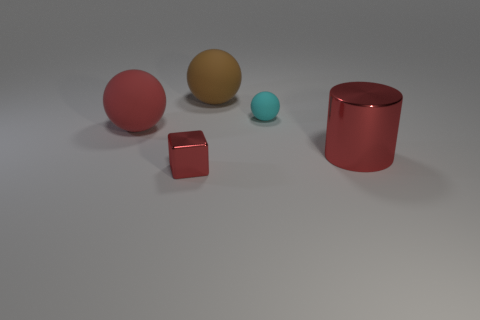How many tiny things are either green shiny objects or matte balls?
Make the answer very short. 1. There is a small thing that is made of the same material as the cylinder; what is its shape?
Keep it short and to the point. Cube. Are there fewer rubber spheres that are right of the cyan sphere than small shiny objects?
Offer a very short reply. Yes. Do the tiny red metallic object and the large shiny thing have the same shape?
Offer a terse response. No. How many metal things are large red things or small red cubes?
Your answer should be compact. 2. Are there any brown spheres of the same size as the red ball?
Make the answer very short. Yes. What is the shape of the shiny object that is the same color as the small block?
Provide a succinct answer. Cylinder. What number of red metallic cylinders are the same size as the red matte object?
Keep it short and to the point. 1. There is a object to the right of the tiny ball; is it the same size as the thing on the left side of the cube?
Your answer should be compact. Yes. How many objects are either gray shiny balls or matte spheres that are in front of the cyan thing?
Ensure brevity in your answer.  1. 